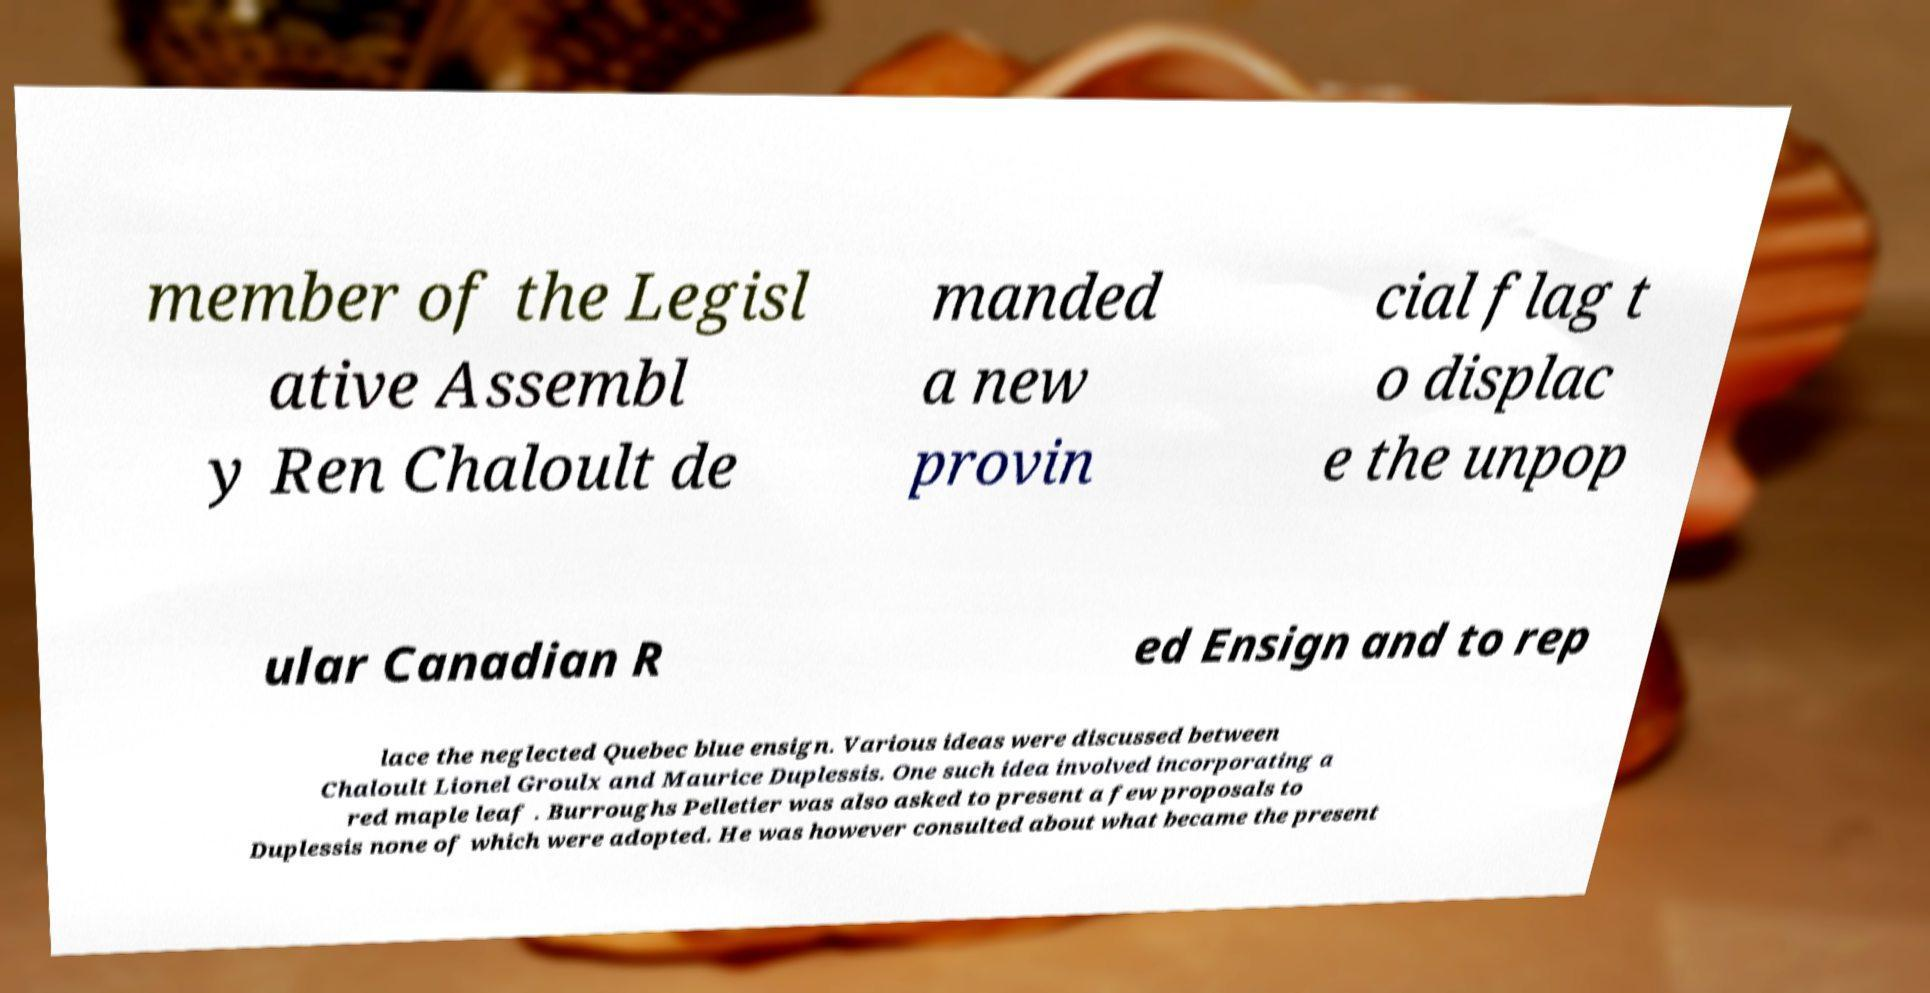Can you read and provide the text displayed in the image?This photo seems to have some interesting text. Can you extract and type it out for me? member of the Legisl ative Assembl y Ren Chaloult de manded a new provin cial flag t o displac e the unpop ular Canadian R ed Ensign and to rep lace the neglected Quebec blue ensign. Various ideas were discussed between Chaloult Lionel Groulx and Maurice Duplessis. One such idea involved incorporating a red maple leaf . Burroughs Pelletier was also asked to present a few proposals to Duplessis none of which were adopted. He was however consulted about what became the present 